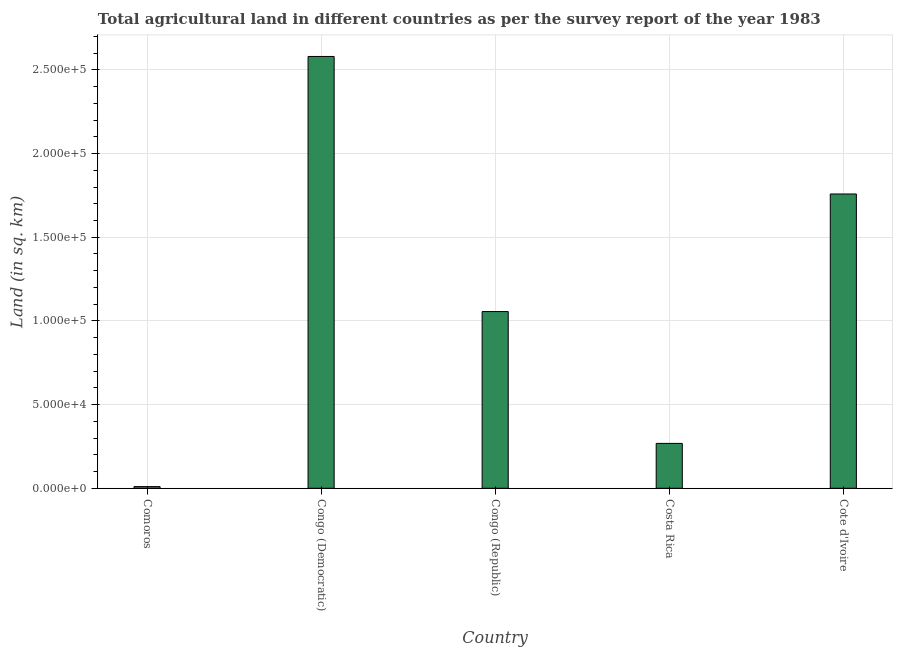What is the title of the graph?
Your response must be concise. Total agricultural land in different countries as per the survey report of the year 1983. What is the label or title of the X-axis?
Ensure brevity in your answer.  Country. What is the label or title of the Y-axis?
Provide a succinct answer. Land (in sq. km). What is the agricultural land in Congo (Republic)?
Make the answer very short. 1.06e+05. Across all countries, what is the maximum agricultural land?
Keep it short and to the point. 2.58e+05. Across all countries, what is the minimum agricultural land?
Give a very brief answer. 1000. In which country was the agricultural land maximum?
Keep it short and to the point. Congo (Democratic). In which country was the agricultural land minimum?
Keep it short and to the point. Comoros. What is the sum of the agricultural land?
Make the answer very short. 5.67e+05. What is the difference between the agricultural land in Comoros and Congo (Democratic)?
Provide a succinct answer. -2.57e+05. What is the average agricultural land per country?
Your answer should be very brief. 1.13e+05. What is the median agricultural land?
Offer a very short reply. 1.06e+05. Is the agricultural land in Comoros less than that in Congo (Democratic)?
Offer a terse response. Yes. What is the difference between the highest and the second highest agricultural land?
Keep it short and to the point. 8.22e+04. Is the sum of the agricultural land in Congo (Republic) and Cote d'Ivoire greater than the maximum agricultural land across all countries?
Give a very brief answer. Yes. What is the difference between the highest and the lowest agricultural land?
Keep it short and to the point. 2.57e+05. In how many countries, is the agricultural land greater than the average agricultural land taken over all countries?
Offer a very short reply. 2. How many bars are there?
Give a very brief answer. 5. Are all the bars in the graph horizontal?
Provide a succinct answer. No. How many countries are there in the graph?
Offer a terse response. 5. What is the Land (in sq. km) in Comoros?
Offer a terse response. 1000. What is the Land (in sq. km) in Congo (Democratic)?
Make the answer very short. 2.58e+05. What is the Land (in sq. km) in Congo (Republic)?
Your answer should be very brief. 1.06e+05. What is the Land (in sq. km) in Costa Rica?
Give a very brief answer. 2.68e+04. What is the Land (in sq. km) in Cote d'Ivoire?
Give a very brief answer. 1.76e+05. What is the difference between the Land (in sq. km) in Comoros and Congo (Democratic)?
Your response must be concise. -2.57e+05. What is the difference between the Land (in sq. km) in Comoros and Congo (Republic)?
Ensure brevity in your answer.  -1.05e+05. What is the difference between the Land (in sq. km) in Comoros and Costa Rica?
Keep it short and to the point. -2.58e+04. What is the difference between the Land (in sq. km) in Comoros and Cote d'Ivoire?
Make the answer very short. -1.75e+05. What is the difference between the Land (in sq. km) in Congo (Democratic) and Congo (Republic)?
Give a very brief answer. 1.52e+05. What is the difference between the Land (in sq. km) in Congo (Democratic) and Costa Rica?
Your response must be concise. 2.31e+05. What is the difference between the Land (in sq. km) in Congo (Democratic) and Cote d'Ivoire?
Your response must be concise. 8.22e+04. What is the difference between the Land (in sq. km) in Congo (Republic) and Costa Rica?
Ensure brevity in your answer.  7.88e+04. What is the difference between the Land (in sq. km) in Congo (Republic) and Cote d'Ivoire?
Your response must be concise. -7.03e+04. What is the difference between the Land (in sq. km) in Costa Rica and Cote d'Ivoire?
Your answer should be very brief. -1.49e+05. What is the ratio of the Land (in sq. km) in Comoros to that in Congo (Democratic)?
Provide a short and direct response. 0. What is the ratio of the Land (in sq. km) in Comoros to that in Congo (Republic)?
Offer a terse response. 0.01. What is the ratio of the Land (in sq. km) in Comoros to that in Costa Rica?
Provide a short and direct response. 0.04. What is the ratio of the Land (in sq. km) in Comoros to that in Cote d'Ivoire?
Give a very brief answer. 0.01. What is the ratio of the Land (in sq. km) in Congo (Democratic) to that in Congo (Republic)?
Offer a very short reply. 2.44. What is the ratio of the Land (in sq. km) in Congo (Democratic) to that in Costa Rica?
Make the answer very short. 9.62. What is the ratio of the Land (in sq. km) in Congo (Democratic) to that in Cote d'Ivoire?
Provide a short and direct response. 1.47. What is the ratio of the Land (in sq. km) in Congo (Republic) to that in Costa Rica?
Offer a very short reply. 3.94. What is the ratio of the Land (in sq. km) in Congo (Republic) to that in Cote d'Ivoire?
Provide a succinct answer. 0.6. What is the ratio of the Land (in sq. km) in Costa Rica to that in Cote d'Ivoire?
Your answer should be compact. 0.15. 